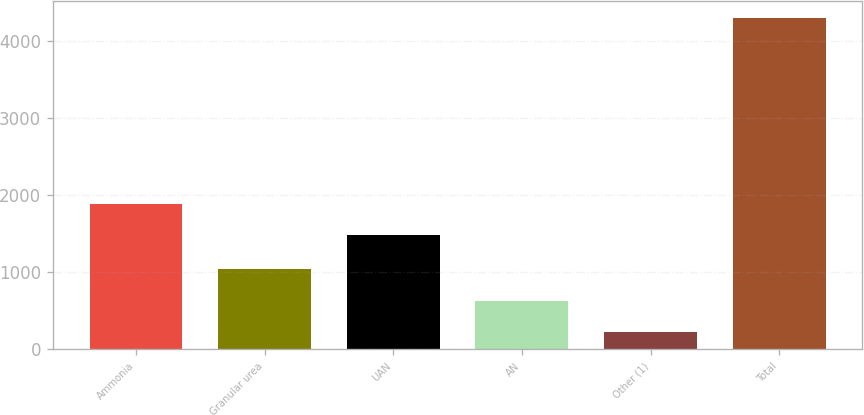Convert chart to OTSL. <chart><loc_0><loc_0><loc_500><loc_500><bar_chart><fcel>Ammonia<fcel>Granular urea<fcel>UAN<fcel>AN<fcel>Other (1)<fcel>Total<nl><fcel>1888.5<fcel>1040<fcel>1480<fcel>631.5<fcel>223<fcel>4308<nl></chart> 